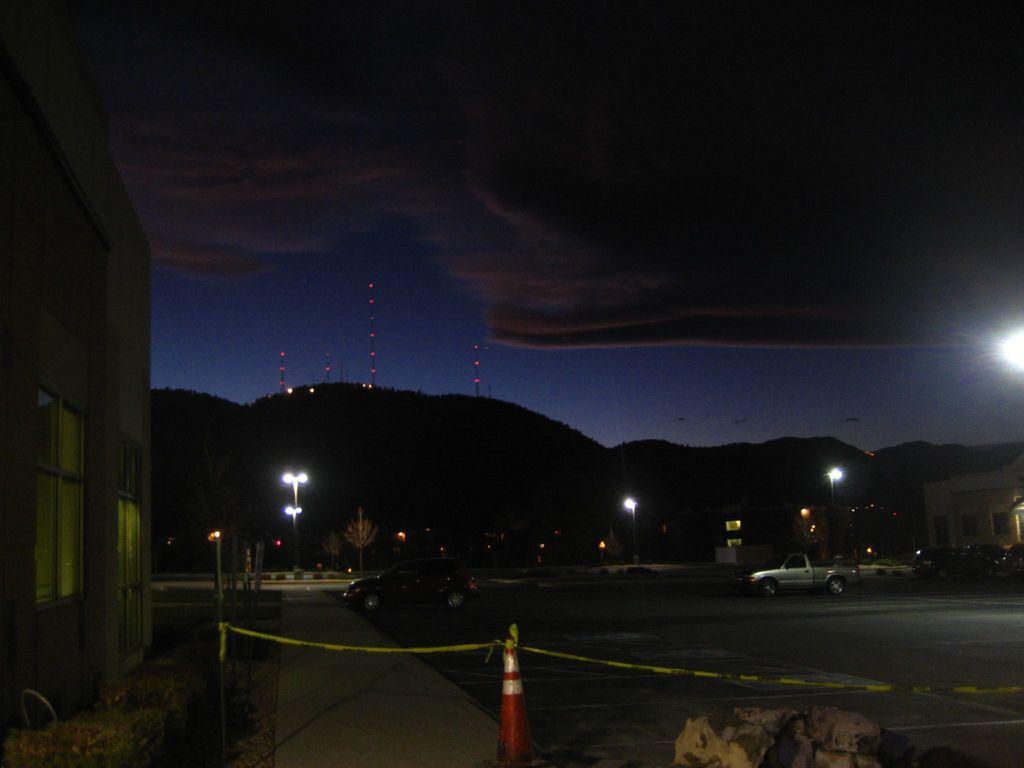Could you give a brief overview of what you see in this image? In the image we can see an outside view. In the foreground of the image we can see two cars parked on the ground. To the left side of the image we can see a building with windows. In the background, we can see a group of police, lights and sky. 